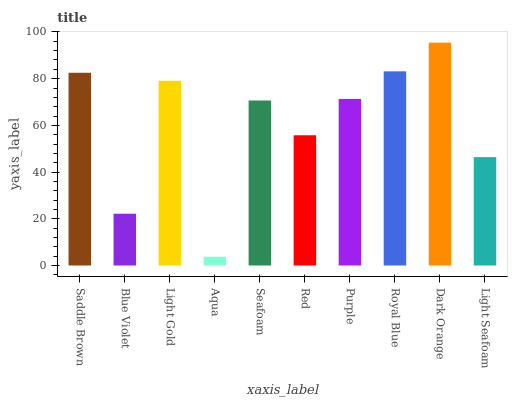Is Blue Violet the minimum?
Answer yes or no. No. Is Blue Violet the maximum?
Answer yes or no. No. Is Saddle Brown greater than Blue Violet?
Answer yes or no. Yes. Is Blue Violet less than Saddle Brown?
Answer yes or no. Yes. Is Blue Violet greater than Saddle Brown?
Answer yes or no. No. Is Saddle Brown less than Blue Violet?
Answer yes or no. No. Is Purple the high median?
Answer yes or no. Yes. Is Seafoam the low median?
Answer yes or no. Yes. Is Seafoam the high median?
Answer yes or no. No. Is Royal Blue the low median?
Answer yes or no. No. 